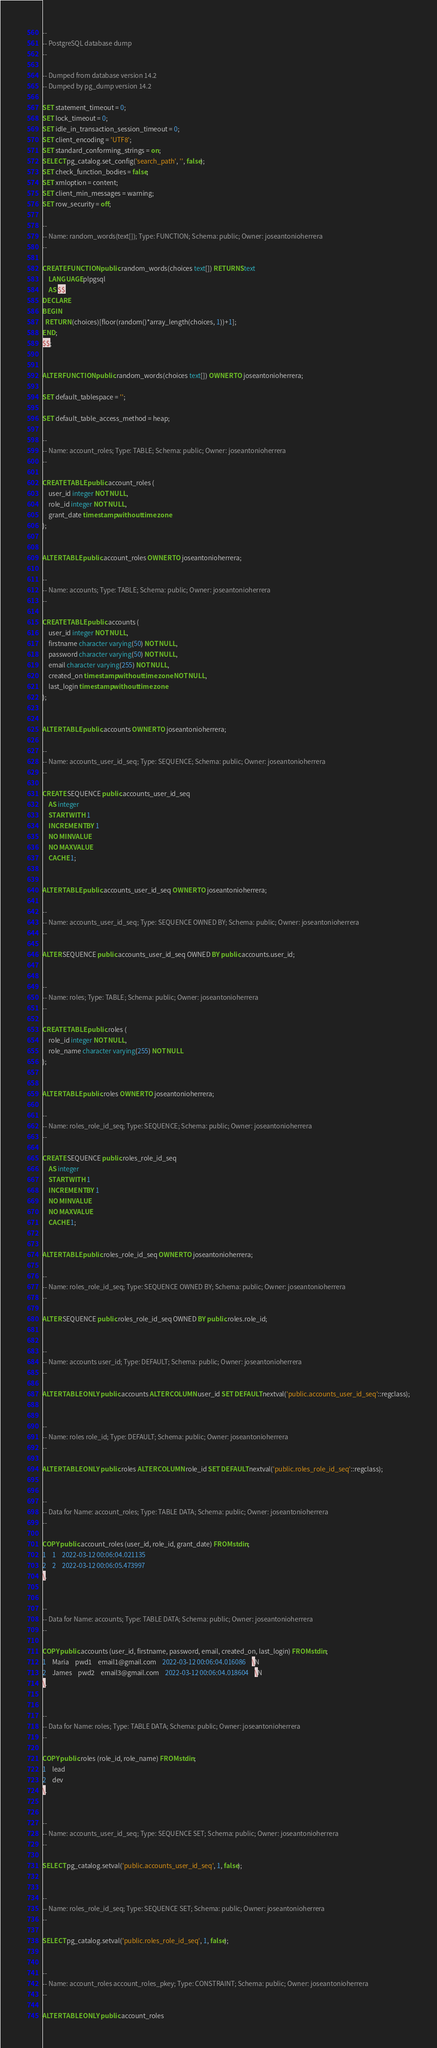Convert code to text. <code><loc_0><loc_0><loc_500><loc_500><_SQL_>--
-- PostgreSQL database dump
--

-- Dumped from database version 14.2
-- Dumped by pg_dump version 14.2

SET statement_timeout = 0;
SET lock_timeout = 0;
SET idle_in_transaction_session_timeout = 0;
SET client_encoding = 'UTF8';
SET standard_conforming_strings = on;
SELECT pg_catalog.set_config('search_path', '', false);
SET check_function_bodies = false;
SET xmloption = content;
SET client_min_messages = warning;
SET row_security = off;

--
-- Name: random_words(text[]); Type: FUNCTION; Schema: public; Owner: joseantonioherrera
--

CREATE FUNCTION public.random_words(choices text[]) RETURNS text
    LANGUAGE plpgsql
    AS $$
DECLARE
BEGIN
  RETURN (choices)[floor(random()*array_length(choices, 1))+1];
END;
$$;


ALTER FUNCTION public.random_words(choices text[]) OWNER TO joseantonioherrera;

SET default_tablespace = '';

SET default_table_access_method = heap;

--
-- Name: account_roles; Type: TABLE; Schema: public; Owner: joseantonioherrera
--

CREATE TABLE public.account_roles (
    user_id integer NOT NULL,
    role_id integer NOT NULL,
    grant_date timestamp without time zone
);


ALTER TABLE public.account_roles OWNER TO joseantonioherrera;

--
-- Name: accounts; Type: TABLE; Schema: public; Owner: joseantonioherrera
--

CREATE TABLE public.accounts (
    user_id integer NOT NULL,
    firstname character varying(50) NOT NULL,
    password character varying(50) NOT NULL,
    email character varying(255) NOT NULL,
    created_on timestamp without time zone NOT NULL,
    last_login timestamp without time zone
);


ALTER TABLE public.accounts OWNER TO joseantonioherrera;

--
-- Name: accounts_user_id_seq; Type: SEQUENCE; Schema: public; Owner: joseantonioherrera
--

CREATE SEQUENCE public.accounts_user_id_seq
    AS integer
    START WITH 1
    INCREMENT BY 1
    NO MINVALUE
    NO MAXVALUE
    CACHE 1;


ALTER TABLE public.accounts_user_id_seq OWNER TO joseantonioherrera;

--
-- Name: accounts_user_id_seq; Type: SEQUENCE OWNED BY; Schema: public; Owner: joseantonioherrera
--

ALTER SEQUENCE public.accounts_user_id_seq OWNED BY public.accounts.user_id;


--
-- Name: roles; Type: TABLE; Schema: public; Owner: joseantonioherrera
--

CREATE TABLE public.roles (
    role_id integer NOT NULL,
    role_name character varying(255) NOT NULL
);


ALTER TABLE public.roles OWNER TO joseantonioherrera;

--
-- Name: roles_role_id_seq; Type: SEQUENCE; Schema: public; Owner: joseantonioherrera
--

CREATE SEQUENCE public.roles_role_id_seq
    AS integer
    START WITH 1
    INCREMENT BY 1
    NO MINVALUE
    NO MAXVALUE
    CACHE 1;


ALTER TABLE public.roles_role_id_seq OWNER TO joseantonioherrera;

--
-- Name: roles_role_id_seq; Type: SEQUENCE OWNED BY; Schema: public; Owner: joseantonioherrera
--

ALTER SEQUENCE public.roles_role_id_seq OWNED BY public.roles.role_id;


--
-- Name: accounts user_id; Type: DEFAULT; Schema: public; Owner: joseantonioherrera
--

ALTER TABLE ONLY public.accounts ALTER COLUMN user_id SET DEFAULT nextval('public.accounts_user_id_seq'::regclass);


--
-- Name: roles role_id; Type: DEFAULT; Schema: public; Owner: joseantonioherrera
--

ALTER TABLE ONLY public.roles ALTER COLUMN role_id SET DEFAULT nextval('public.roles_role_id_seq'::regclass);


--
-- Data for Name: account_roles; Type: TABLE DATA; Schema: public; Owner: joseantonioherrera
--

COPY public.account_roles (user_id, role_id, grant_date) FROM stdin;
1	1	2022-03-12 00:06:04.021135
2	2	2022-03-12 00:06:05.473997
\.


--
-- Data for Name: accounts; Type: TABLE DATA; Schema: public; Owner: joseantonioherrera
--

COPY public.accounts (user_id, firstname, password, email, created_on, last_login) FROM stdin;
1	Maria	pwd1	email1@gmail.com	2022-03-12 00:06:04.016086	\N
2	James	pwd2	email3@gmail.com	2022-03-12 00:06:04.018604	\N
\.


--
-- Data for Name: roles; Type: TABLE DATA; Schema: public; Owner: joseantonioherrera
--

COPY public.roles (role_id, role_name) FROM stdin;
1	lead
2	dev
\.


--
-- Name: accounts_user_id_seq; Type: SEQUENCE SET; Schema: public; Owner: joseantonioherrera
--

SELECT pg_catalog.setval('public.accounts_user_id_seq', 1, false);


--
-- Name: roles_role_id_seq; Type: SEQUENCE SET; Schema: public; Owner: joseantonioherrera
--

SELECT pg_catalog.setval('public.roles_role_id_seq', 1, false);


--
-- Name: account_roles account_roles_pkey; Type: CONSTRAINT; Schema: public; Owner: joseantonioherrera
--

ALTER TABLE ONLY public.account_roles</code> 